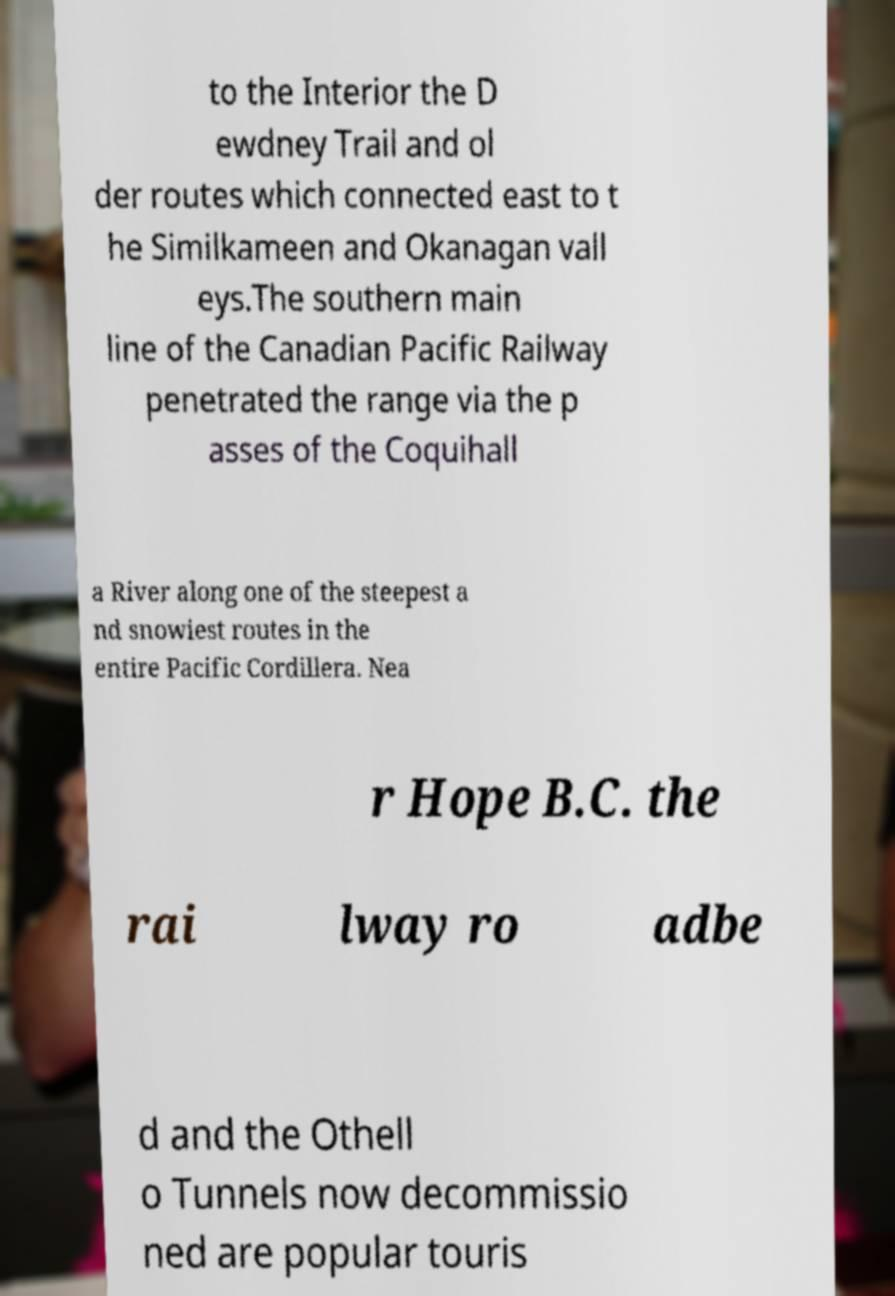Please read and relay the text visible in this image. What does it say? to the Interior the D ewdney Trail and ol der routes which connected east to t he Similkameen and Okanagan vall eys.The southern main line of the Canadian Pacific Railway penetrated the range via the p asses of the Coquihall a River along one of the steepest a nd snowiest routes in the entire Pacific Cordillera. Nea r Hope B.C. the rai lway ro adbe d and the Othell o Tunnels now decommissio ned are popular touris 